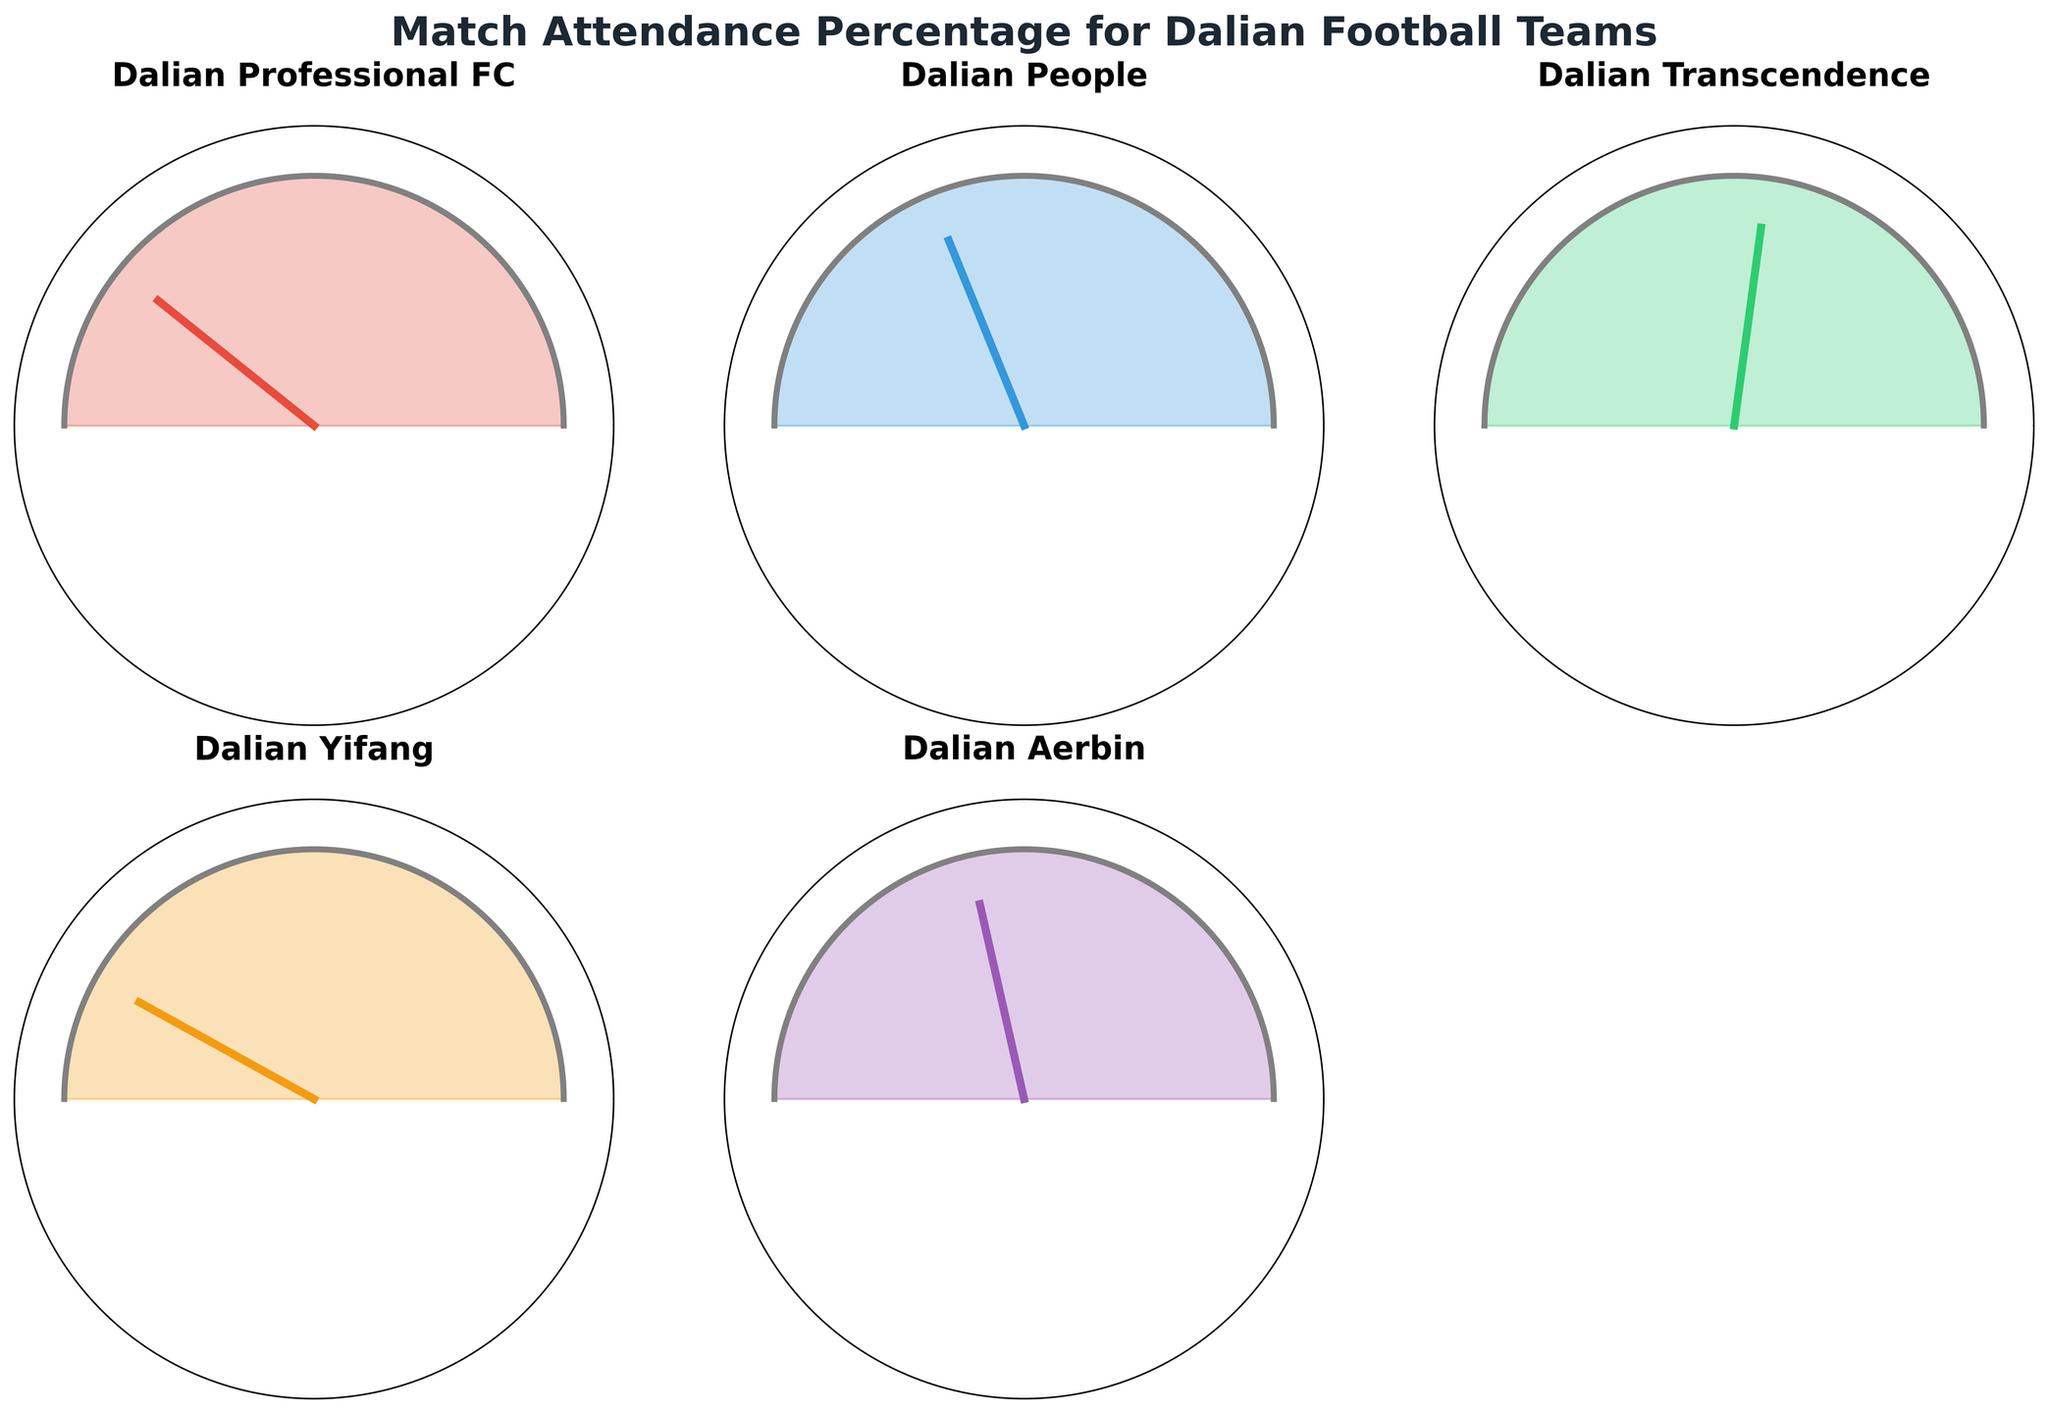What is the title of the figure? The title is located at the top of the figure, providing a summary of what the figure represents.
Answer: Match Attendance Percentage for Dalian Football Teams What is the attendance percentage for Dalian Yifang? Look at the gauge chart labeled "Dalian Yifang" and find the percentage shown near the needle or as text.
Answer: 83.9% Which team has the highest attendance percentage? Compare the attendance percentages of all the teams. The one with the highest percentage is the answer.
Answer: Dalian Yifang Which team has the lowest attendance percentage? Compare the attendance percentages of all the teams. The one with the lowest percentage is the answer.
Answer: Dalian Transcendence What is the average attendance percentage for all the teams? Sum all the attendance percentages and divide by the number of teams: (78.5 + 62.3 + 45.7 + 83.9 + 57.1) / 5.
Answer: 65.5% How many teams have an attendance percentage above 70%? Check each team's percentage and count how many exceed 70%.
Answer: 2 Which team has a higher attendance rate, Dalian Professional FC or Dalian Aerbin? Compare the attendance percentages of both teams, 78.5% for Dalian Professional FC and 57.1% for Dalian Aerbin.
Answer: Dalian Professional FC What is the difference in attendance percentage between Dalian People and Dalian Transcendence? Subtract the attendance percentage of Dalian Transcendence from that of Dalian People: 62.3 - 45.7.
Answer: 16.6% Is there any team with an attendance percentage exactly in the middle of the highest and lowest percentages? Find the median value between the highest (83.9) and lowest (45.7) percentages. None of the teams has exactly this percentage.
Answer: No Which team has an attendance percentage closest to 60%? Compare each team's attendance percentage to 60% and find the closest one.
Answer: Dalian People 